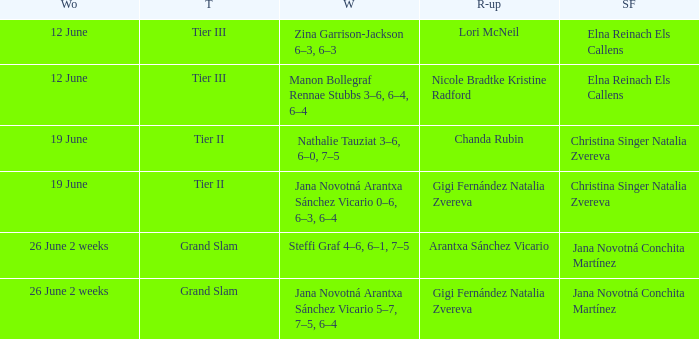In which week is the winner listed as Jana Novotná Arantxa Sánchez Vicario 5–7, 7–5, 6–4? 26 June 2 weeks. 